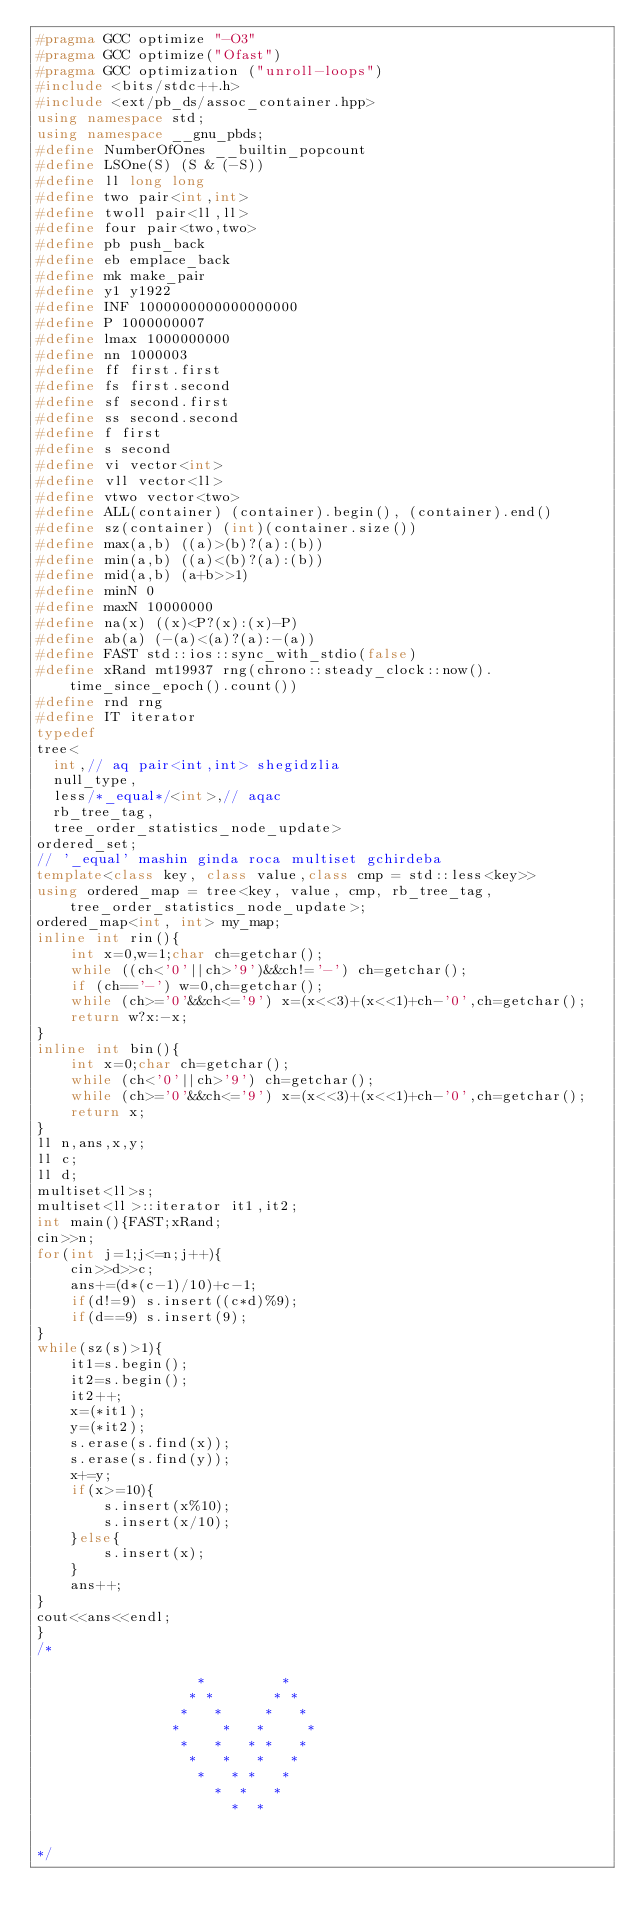Convert code to text. <code><loc_0><loc_0><loc_500><loc_500><_C++_>#pragma GCC optimize "-O3"
#pragma GCC optimize("Ofast")
#pragma GCC optimization ("unroll-loops")
#include <bits/stdc++.h>
#include <ext/pb_ds/assoc_container.hpp>
using namespace std;
using namespace __gnu_pbds;
#define NumberOfOnes __builtin_popcount
#define LSOne(S) (S & (-S))
#define ll long long
#define two pair<int,int>
#define twoll pair<ll,ll>
#define four pair<two,two>
#define pb push_back
#define eb emplace_back
#define mk make_pair
#define y1 y1922
#define INF 1000000000000000000
#define P 1000000007
#define lmax 1000000000
#define nn 1000003
#define ff first.first
#define fs first.second
#define sf second.first
#define ss second.second
#define f first
#define s second
#define vi vector<int>
#define vll vector<ll>
#define vtwo vector<two>
#define ALL(container) (container).begin(), (container).end()
#define sz(container) (int)(container.size())
#define max(a,b) ((a)>(b)?(a):(b))
#define min(a,b) ((a)<(b)?(a):(b))
#define mid(a,b) (a+b>>1)
#define minN 0
#define maxN 10000000
#define na(x) ((x)<P?(x):(x)-P)
#define ab(a) (-(a)<(a)?(a):-(a))
#define FAST std::ios::sync_with_stdio(false)
#define xRand mt19937 rng(chrono::steady_clock::now().time_since_epoch().count())
#define rnd rng
#define IT iterator
typedef
tree<
  int,// aq pair<int,int> shegidzlia
  null_type,
  less/*_equal*/<int>,// aqac
  rb_tree_tag,
  tree_order_statistics_node_update>
ordered_set;
// '_equal' mashin ginda roca multiset gchirdeba
template<class key, class value,class cmp = std::less<key>>
using ordered_map = tree<key, value, cmp, rb_tree_tag, tree_order_statistics_node_update>;
ordered_map<int, int> my_map;
inline int rin(){
	int x=0,w=1;char ch=getchar();
	while ((ch<'0'||ch>'9')&&ch!='-') ch=getchar();
	if (ch=='-') w=0,ch=getchar();
	while (ch>='0'&&ch<='9') x=(x<<3)+(x<<1)+ch-'0',ch=getchar();
	return w?x:-x;
}
inline int bin(){
	int x=0;char ch=getchar();
	while (ch<'0'||ch>'9') ch=getchar();
	while (ch>='0'&&ch<='9') x=(x<<3)+(x<<1)+ch-'0',ch=getchar();
	return x;
}
ll n,ans,x,y;
ll c;
ll d;
multiset<ll>s;
multiset<ll>::iterator it1,it2;
int main(){FAST;xRand;
cin>>n;
for(int j=1;j<=n;j++){
	cin>>d>>c;
	ans+=(d*(c-1)/10)+c-1;
	if(d!=9) s.insert((c*d)%9);
	if(d==9) s.insert(9);
}
while(sz(s)>1){
	it1=s.begin();
	it2=s.begin();
	it2++;
	x=(*it1);
	y=(*it2);
	s.erase(s.find(x));
	s.erase(s.find(y));
	x+=y;
	if(x>=10){
		s.insert(x%10);
		s.insert(x/10);
	}else{
		s.insert(x);
	}
	ans++;
}
cout<<ans<<endl;
}
/*

                   *         *
                  * *       * *
                 *   *     *   *
                *     *   *     *
                 *   *   * *   *
                  *   *   *   *
                   *   * *   *
                     *  *   *
					   *  *


*/

</code> 